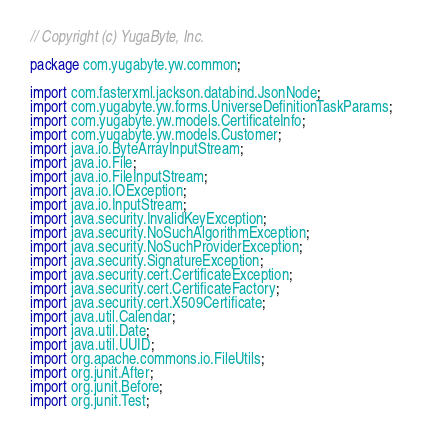Convert code to text. <code><loc_0><loc_0><loc_500><loc_500><_Java_>// Copyright (c) YugaByte, Inc.

package com.yugabyte.yw.common;

import com.fasterxml.jackson.databind.JsonNode;
import com.yugabyte.yw.forms.UniverseDefinitionTaskParams;
import com.yugabyte.yw.models.CertificateInfo;
import com.yugabyte.yw.models.Customer;
import java.io.ByteArrayInputStream;
import java.io.File;
import java.io.FileInputStream;
import java.io.IOException;
import java.io.InputStream;
import java.security.InvalidKeyException;
import java.security.NoSuchAlgorithmException;
import java.security.NoSuchProviderException;
import java.security.SignatureException;
import java.security.cert.CertificateException;
import java.security.cert.CertificateFactory;
import java.security.cert.X509Certificate;
import java.util.Calendar;
import java.util.Date;
import java.util.UUID;
import org.apache.commons.io.FileUtils;
import org.junit.After;
import org.junit.Before;
import org.junit.Test;</code> 